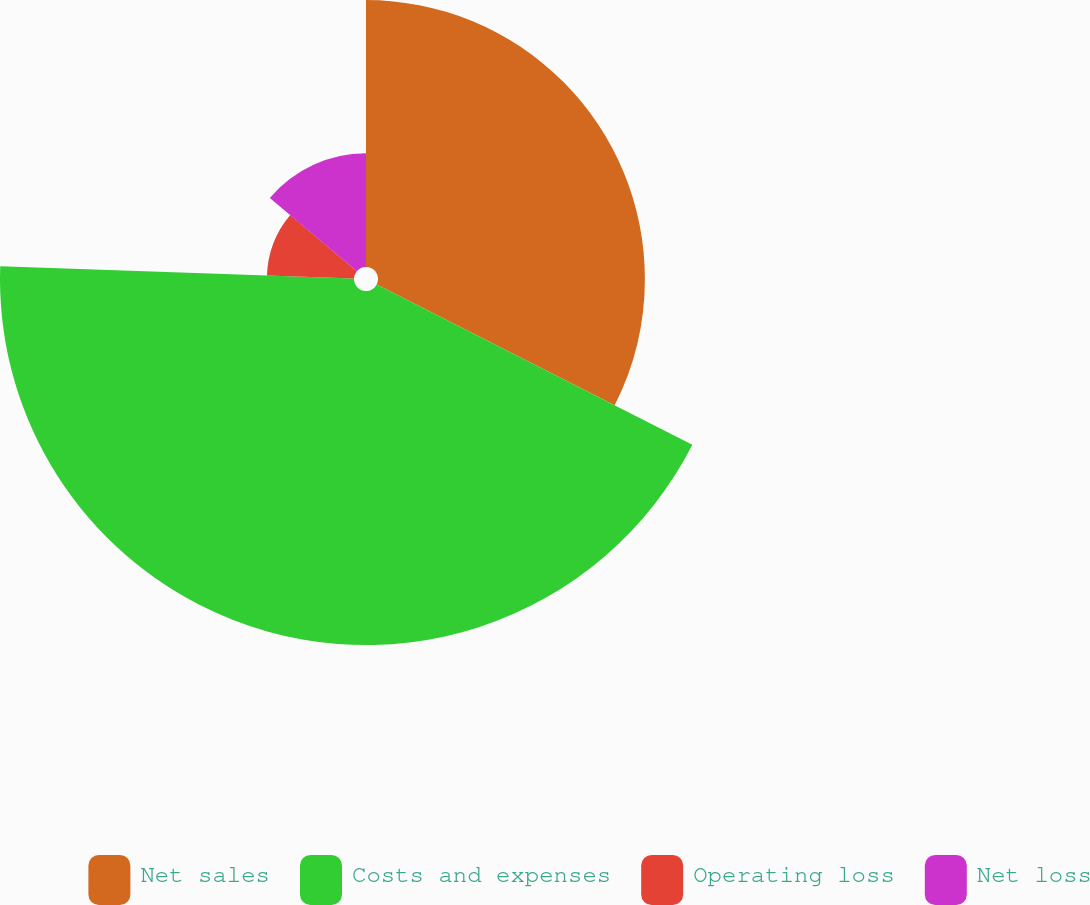<chart> <loc_0><loc_0><loc_500><loc_500><pie_chart><fcel>Net sales<fcel>Costs and expenses<fcel>Operating loss<fcel>Net loss<nl><fcel>32.48%<fcel>43.08%<fcel>10.6%<fcel>13.85%<nl></chart> 